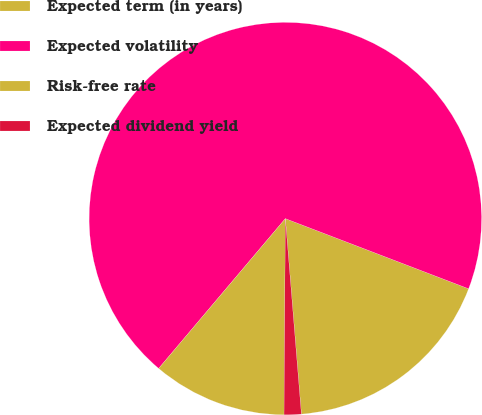<chart> <loc_0><loc_0><loc_500><loc_500><pie_chart><fcel>Expected term (in years)<fcel>Expected volatility<fcel>Risk-free rate<fcel>Expected dividend yield<nl><fcel>17.88%<fcel>69.65%<fcel>11.06%<fcel>1.41%<nl></chart> 